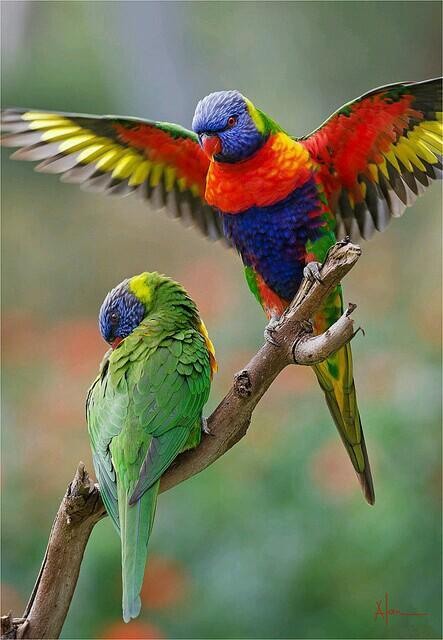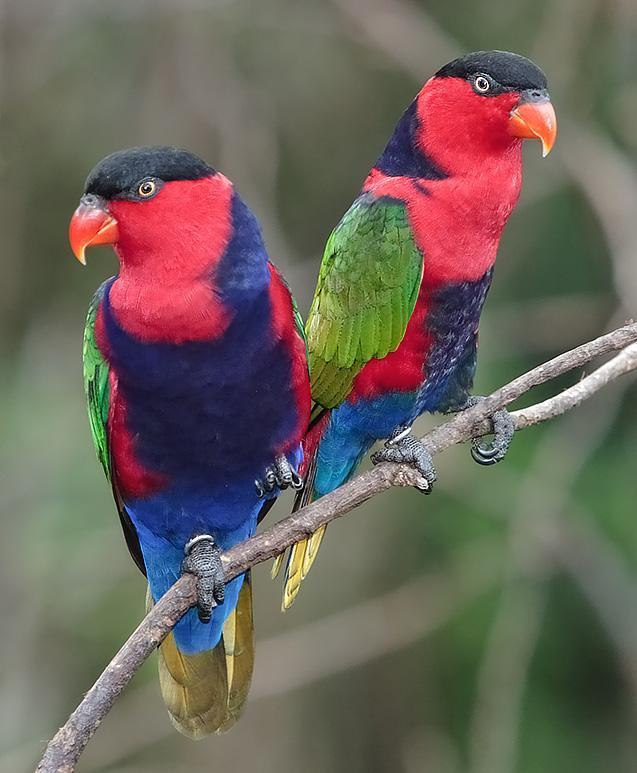The first image is the image on the left, the second image is the image on the right. Evaluate the accuracy of this statement regarding the images: "The parrots in the two images are looking toward each other.". Is it true? Answer yes or no. No. The first image is the image on the left, the second image is the image on the right. For the images shown, is this caption "A single bird perches on a branch with leaves on it." true? Answer yes or no. No. 